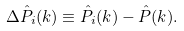Convert formula to latex. <formula><loc_0><loc_0><loc_500><loc_500>\Delta { \hat { P } _ { i } ( k ) } \equiv \hat { P } _ { i } ( k ) - \hat { P } ( k ) .</formula> 